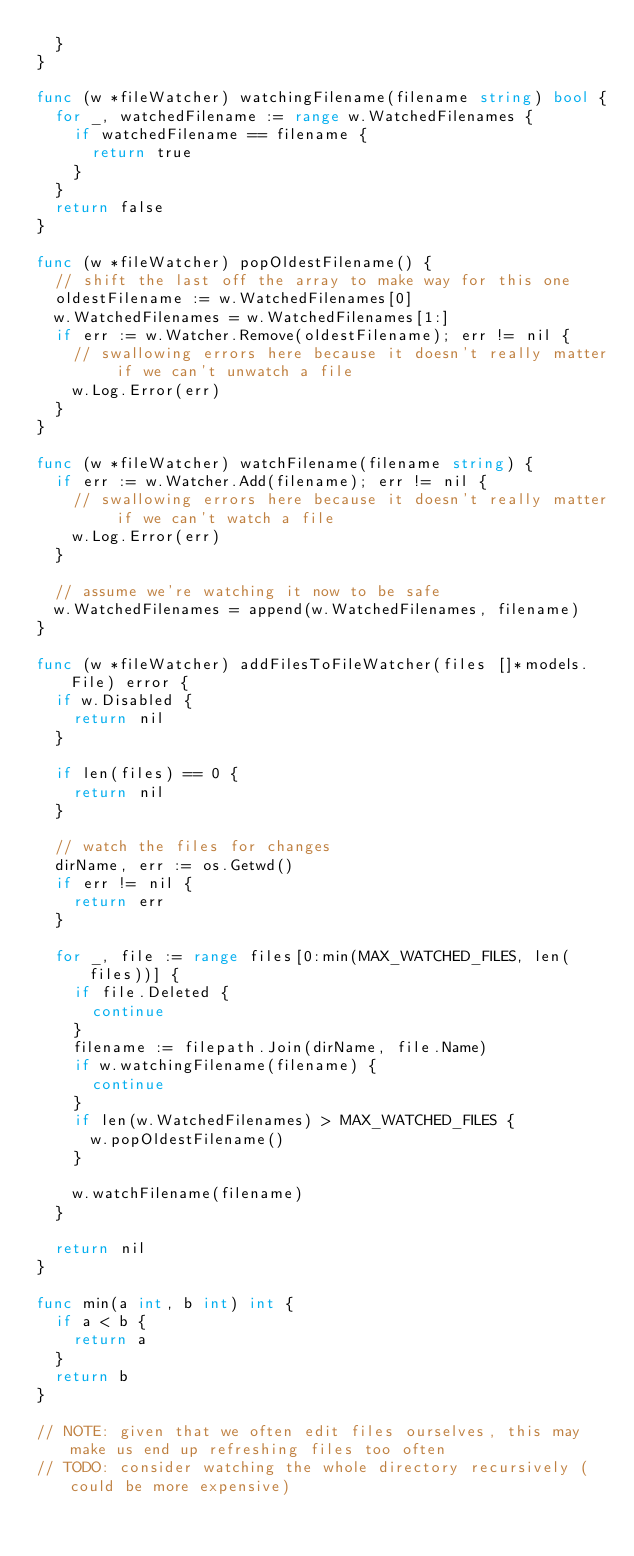Convert code to text. <code><loc_0><loc_0><loc_500><loc_500><_Go_>	}
}

func (w *fileWatcher) watchingFilename(filename string) bool {
	for _, watchedFilename := range w.WatchedFilenames {
		if watchedFilename == filename {
			return true
		}
	}
	return false
}

func (w *fileWatcher) popOldestFilename() {
	// shift the last off the array to make way for this one
	oldestFilename := w.WatchedFilenames[0]
	w.WatchedFilenames = w.WatchedFilenames[1:]
	if err := w.Watcher.Remove(oldestFilename); err != nil {
		// swallowing errors here because it doesn't really matter if we can't unwatch a file
		w.Log.Error(err)
	}
}

func (w *fileWatcher) watchFilename(filename string) {
	if err := w.Watcher.Add(filename); err != nil {
		// swallowing errors here because it doesn't really matter if we can't watch a file
		w.Log.Error(err)
	}

	// assume we're watching it now to be safe
	w.WatchedFilenames = append(w.WatchedFilenames, filename)
}

func (w *fileWatcher) addFilesToFileWatcher(files []*models.File) error {
	if w.Disabled {
		return nil
	}

	if len(files) == 0 {
		return nil
	}

	// watch the files for changes
	dirName, err := os.Getwd()
	if err != nil {
		return err
	}

	for _, file := range files[0:min(MAX_WATCHED_FILES, len(files))] {
		if file.Deleted {
			continue
		}
		filename := filepath.Join(dirName, file.Name)
		if w.watchingFilename(filename) {
			continue
		}
		if len(w.WatchedFilenames) > MAX_WATCHED_FILES {
			w.popOldestFilename()
		}

		w.watchFilename(filename)
	}

	return nil
}

func min(a int, b int) int {
	if a < b {
		return a
	}
	return b
}

// NOTE: given that we often edit files ourselves, this may make us end up refreshing files too often
// TODO: consider watching the whole directory recursively (could be more expensive)</code> 